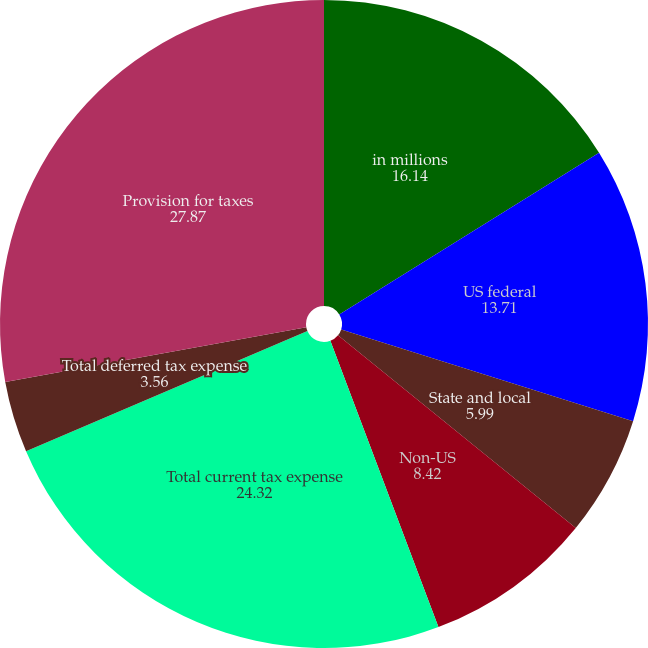Convert chart. <chart><loc_0><loc_0><loc_500><loc_500><pie_chart><fcel>in millions<fcel>US federal<fcel>State and local<fcel>Non-US<fcel>Total current tax expense<fcel>Total deferred tax expense<fcel>Provision for taxes<nl><fcel>16.14%<fcel>13.71%<fcel>5.99%<fcel>8.42%<fcel>24.32%<fcel>3.56%<fcel>27.87%<nl></chart> 